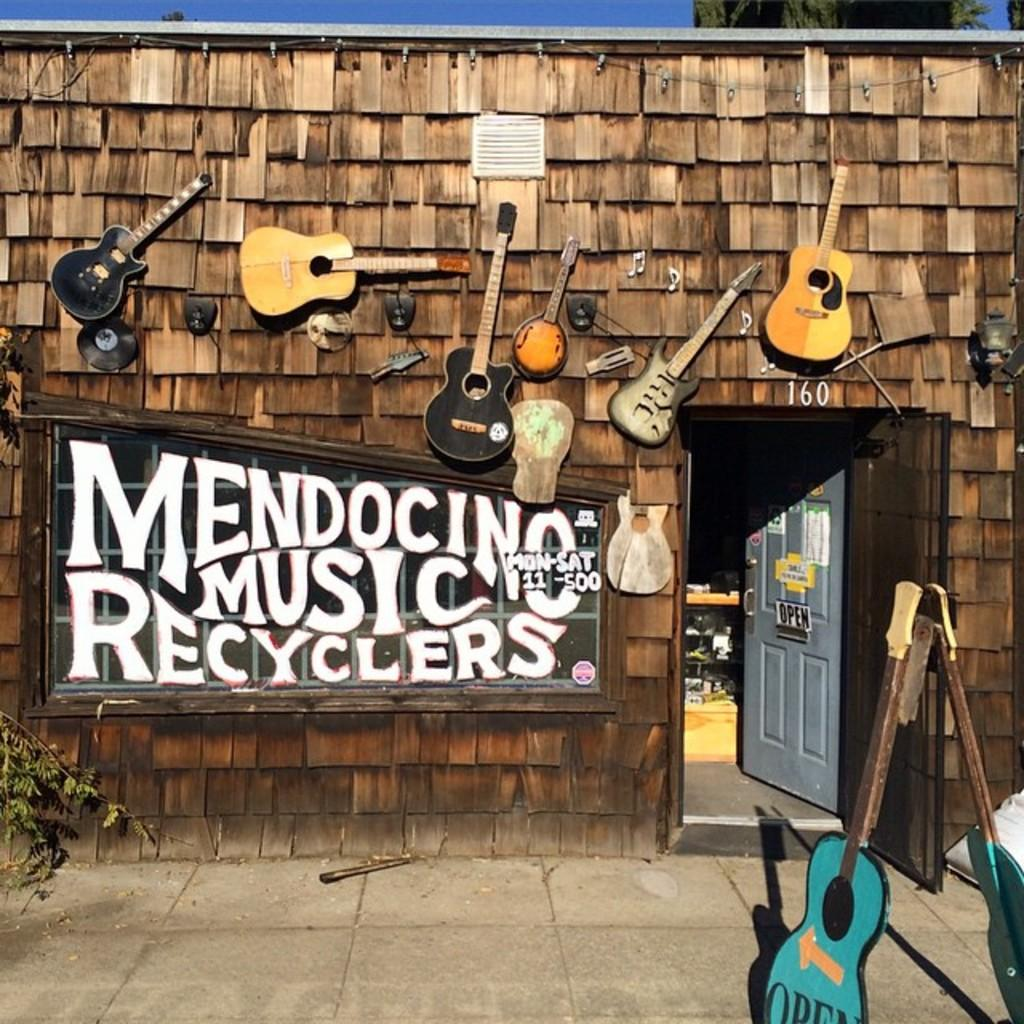What type of musical instruments are present in the image? There are many guitars in the image. Can you describe any other objects or features in the image? There is a board attached to the wall in the image. What type of grape is being used to play the guitar in the image? There are no grapes present in the image, and guitars are not played with grapes. 